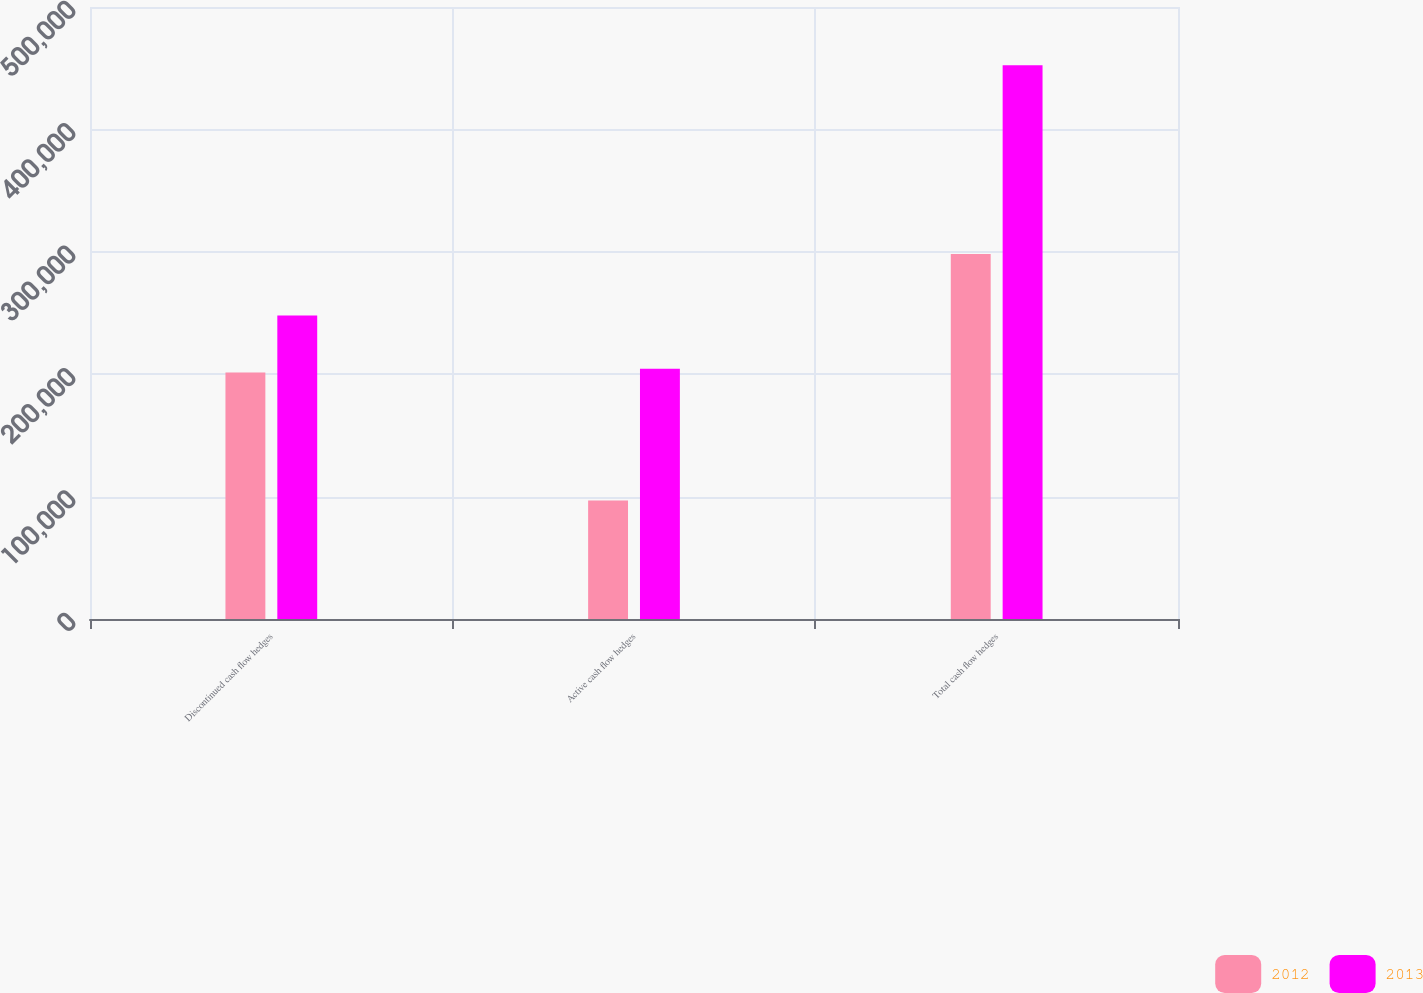Convert chart. <chart><loc_0><loc_0><loc_500><loc_500><stacked_bar_chart><ecel><fcel>Discontinued cash flow hedges<fcel>Active cash flow hedges<fcel>Total cash flow hedges<nl><fcel>2012<fcel>201356<fcel>96754<fcel>298110<nl><fcel>2013<fcel>247983<fcel>204358<fcel>452341<nl></chart> 